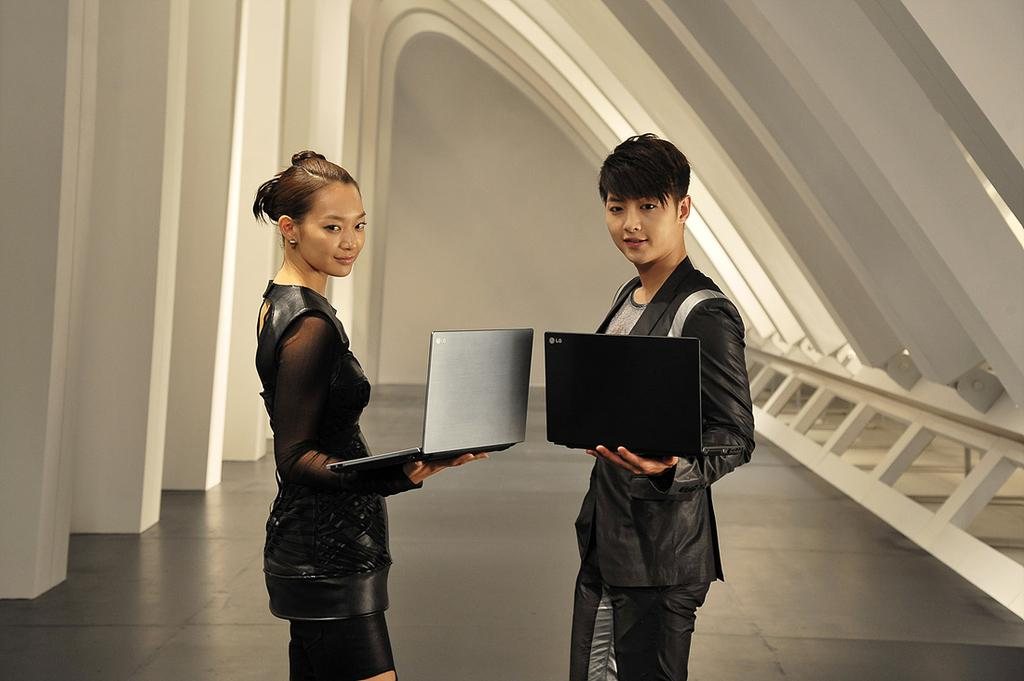How many people are in the foreground of the image? There are two persons in the foreground of the image. What are the persons holding in their hands? The persons are holding laptops in their hands. Where are the persons standing in the image? The persons are standing on the floor. What can be seen in the background of the image? There is a wall in the background of the image. What might be the location of the image? The image may have been taken in a hall. What type of cookware is the person using in the image? There is no cookware or person cooking in the image; it features two persons holding laptops. What time of day is it in the image? The time of day cannot be determined from the image, as there are no clues to suggest whether it is morning, afternoon, or evening. 